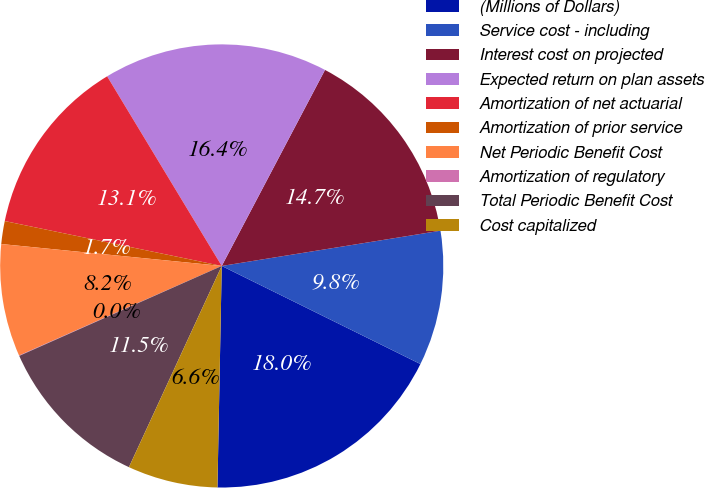<chart> <loc_0><loc_0><loc_500><loc_500><pie_chart><fcel>(Millions of Dollars)<fcel>Service cost - including<fcel>Interest cost on projected<fcel>Expected return on plan assets<fcel>Amortization of net actuarial<fcel>Amortization of prior service<fcel>Net Periodic Benefit Cost<fcel>Amortization of regulatory<fcel>Total Periodic Benefit Cost<fcel>Cost capitalized<nl><fcel>18.01%<fcel>9.84%<fcel>14.74%<fcel>16.37%<fcel>13.1%<fcel>1.67%<fcel>8.2%<fcel>0.03%<fcel>11.47%<fcel>6.57%<nl></chart> 